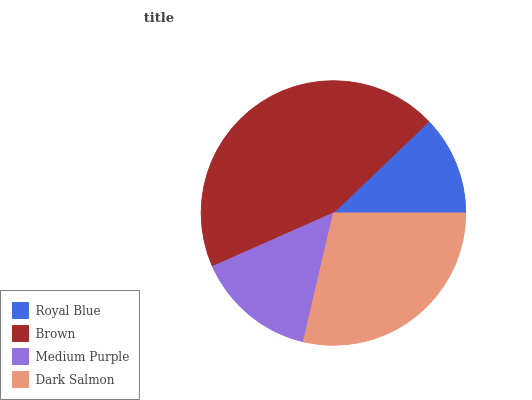Is Royal Blue the minimum?
Answer yes or no. Yes. Is Brown the maximum?
Answer yes or no. Yes. Is Medium Purple the minimum?
Answer yes or no. No. Is Medium Purple the maximum?
Answer yes or no. No. Is Brown greater than Medium Purple?
Answer yes or no. Yes. Is Medium Purple less than Brown?
Answer yes or no. Yes. Is Medium Purple greater than Brown?
Answer yes or no. No. Is Brown less than Medium Purple?
Answer yes or no. No. Is Dark Salmon the high median?
Answer yes or no. Yes. Is Medium Purple the low median?
Answer yes or no. Yes. Is Royal Blue the high median?
Answer yes or no. No. Is Royal Blue the low median?
Answer yes or no. No. 